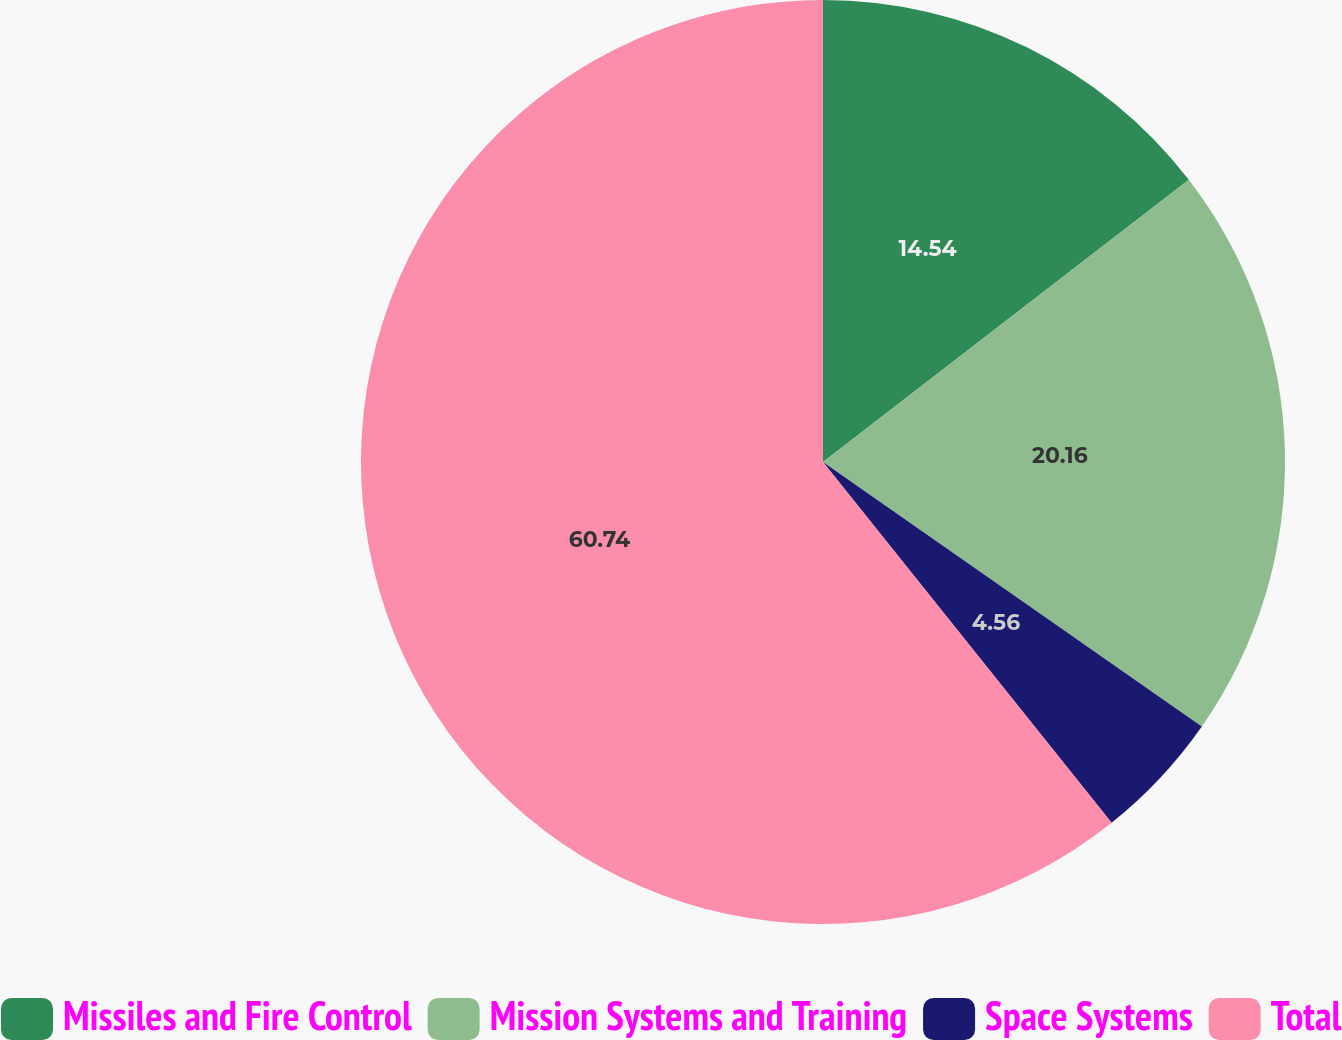Convert chart to OTSL. <chart><loc_0><loc_0><loc_500><loc_500><pie_chart><fcel>Missiles and Fire Control<fcel>Mission Systems and Training<fcel>Space Systems<fcel>Total<nl><fcel>14.54%<fcel>20.16%<fcel>4.56%<fcel>60.74%<nl></chart> 